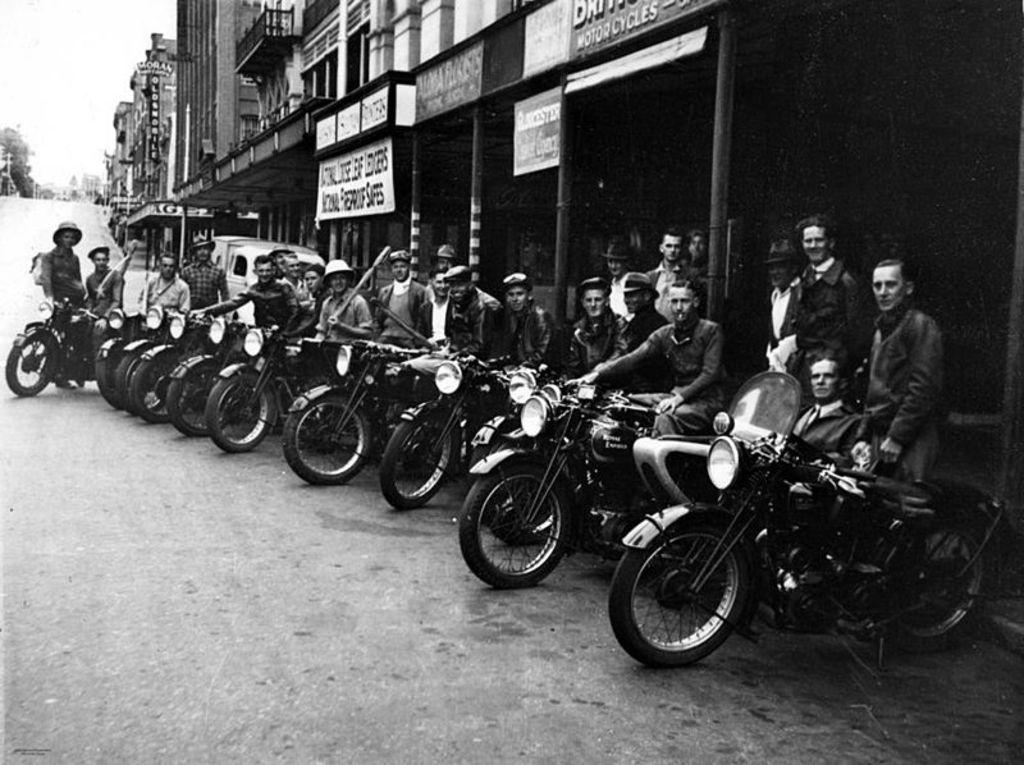What is the main subject of the image? The main subject of the image is many motorbikes. What are the people in the image doing? The people in the image are sitting on the motorbikes. What can be seen in the background of the image? There are many buildings in the background of the image. What type of quicksand can be seen in the image? There is no quicksand present in the image; it features motorbikes and people sitting on them, with buildings in the background. 